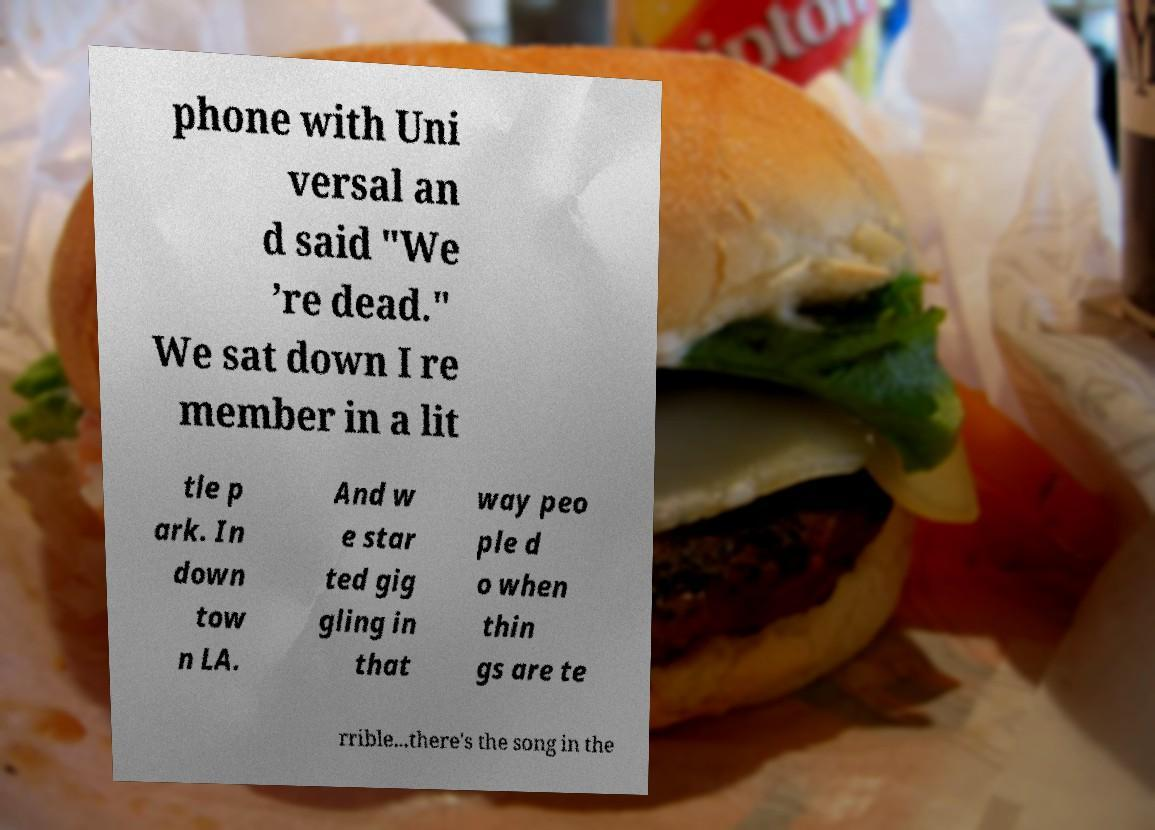I need the written content from this picture converted into text. Can you do that? phone with Uni versal an d said "We ’re dead." We sat down I re member in a lit tle p ark. In down tow n LA. And w e star ted gig gling in that way peo ple d o when thin gs are te rrible...there's the song in the 